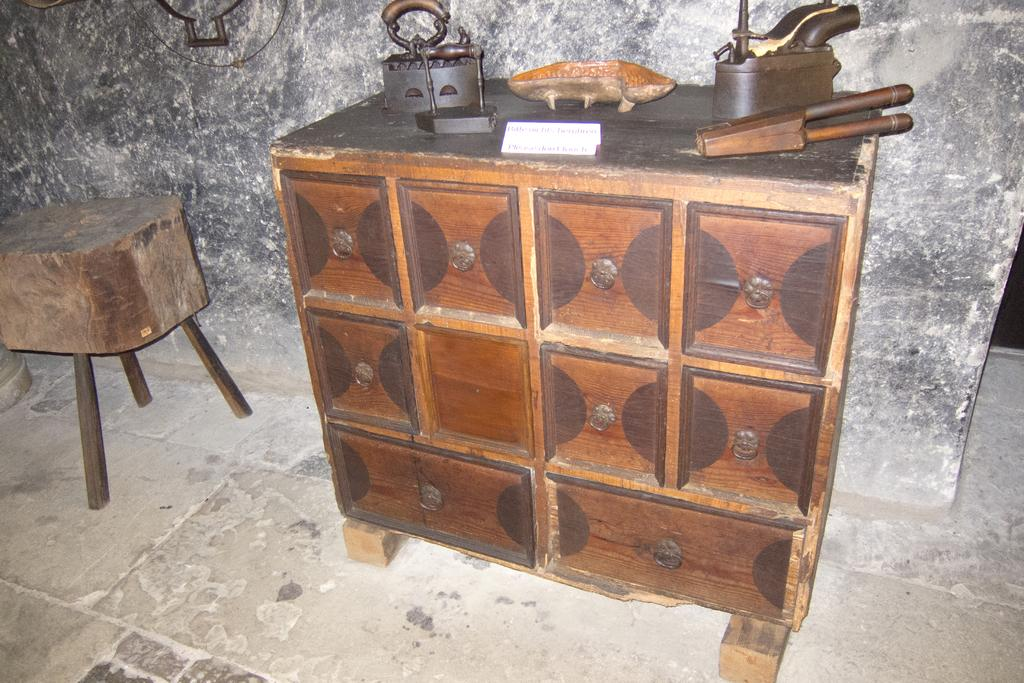What type of table is in the image? There is a wooden table in the image. What is placed on the wooden table? There are two iron boxes on the table. Are there any other objects on the table besides the iron boxes? Yes, there are other objects on the table. What can be seen in the background of the image? There is a rock wall in the background of the image. What type of oatmeal is being served on the table in the image? There is no oatmeal present in the image; the table has two iron boxes and other unspecified objects. 